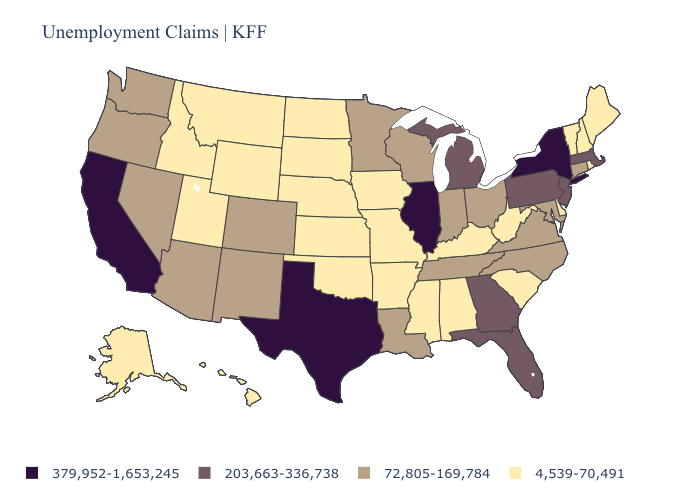What is the highest value in states that border Utah?
Answer briefly. 72,805-169,784. Name the states that have a value in the range 4,539-70,491?
Concise answer only. Alabama, Alaska, Arkansas, Delaware, Hawaii, Idaho, Iowa, Kansas, Kentucky, Maine, Mississippi, Missouri, Montana, Nebraska, New Hampshire, North Dakota, Oklahoma, Rhode Island, South Carolina, South Dakota, Utah, Vermont, West Virginia, Wyoming. Name the states that have a value in the range 203,663-336,738?
Answer briefly. Florida, Georgia, Massachusetts, Michigan, New Jersey, Pennsylvania. What is the lowest value in the USA?
Write a very short answer. 4,539-70,491. Among the states that border Pennsylvania , which have the lowest value?
Be succinct. Delaware, West Virginia. Among the states that border North Dakota , does Montana have the lowest value?
Concise answer only. Yes. What is the value of Iowa?
Short answer required. 4,539-70,491. What is the value of Alabama?
Answer briefly. 4,539-70,491. What is the value of Indiana?
Quick response, please. 72,805-169,784. What is the value of New York?
Short answer required. 379,952-1,653,245. Name the states that have a value in the range 379,952-1,653,245?
Short answer required. California, Illinois, New York, Texas. Name the states that have a value in the range 203,663-336,738?
Concise answer only. Florida, Georgia, Massachusetts, Michigan, New Jersey, Pennsylvania. Which states have the lowest value in the MidWest?
Short answer required. Iowa, Kansas, Missouri, Nebraska, North Dakota, South Dakota. Name the states that have a value in the range 203,663-336,738?
Concise answer only. Florida, Georgia, Massachusetts, Michigan, New Jersey, Pennsylvania. Which states have the highest value in the USA?
Quick response, please. California, Illinois, New York, Texas. 